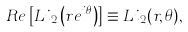Convert formula to latex. <formula><loc_0><loc_0><loc_500><loc_500>R e \left [ L i _ { 2 } \left ( r e ^ { { i } \theta } \right ) \right ] \equiv L i _ { 2 } ( r , \theta ) ,</formula> 